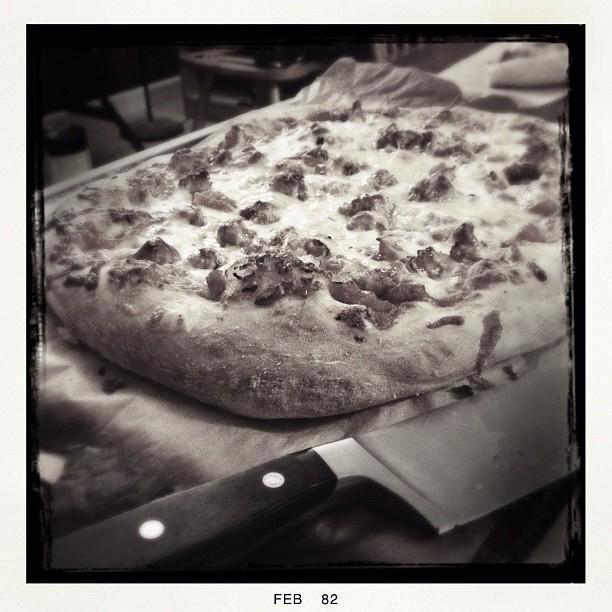How many chairs can be seen?
Give a very brief answer. 1. How many people are wearing glasses?
Give a very brief answer. 0. 